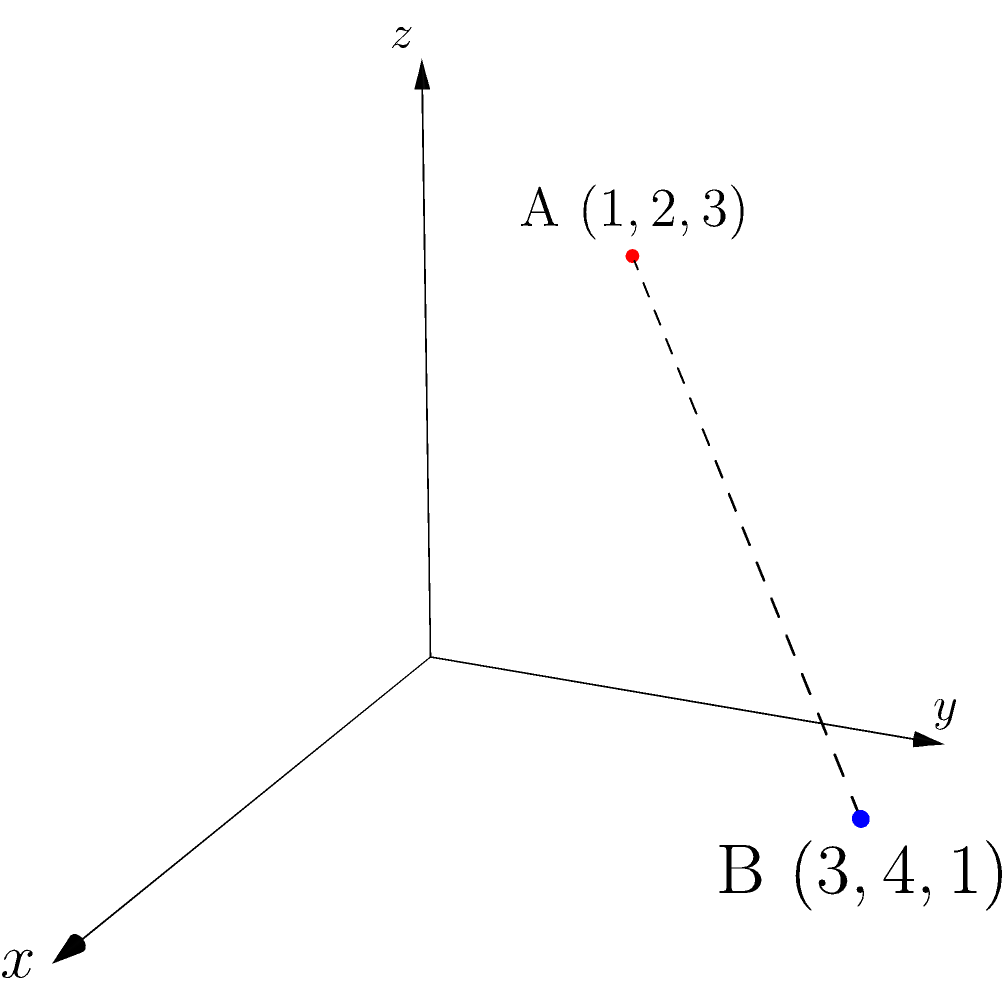In the competitive landscape of quantum computing, two products are represented by points A(1,2,3) and B(3,4,1) in a 3D space where each dimension represents a key technological attribute. Calculate the Euclidean distance between these points to quantify the technological gap between the products. How might this metric inform strategic decisions regarding intellectual property protection and R&D investments? To solve this problem, we'll use the distance formula in 3D space and then interpret the result in the context of technology and intellectual property strategy.

Step 1: Recall the distance formula in 3D space.
For two points $(x_1, y_1, z_1)$ and $(x_2, y_2, z_2)$, the distance $d$ is given by:

$$d = \sqrt{(x_2-x_1)^2 + (y_2-y_1)^2 + (z_2-z_1)^2}$$

Step 2: Identify the coordinates of the two points.
A(1,2,3) and B(3,4,1)

Step 3: Plug the values into the formula.
$$d = \sqrt{(3-1)^2 + (4-2)^2 + (1-3)^2}$$

Step 4: Simplify the expression under the square root.
$$d = \sqrt{2^2 + 2^2 + (-2)^2} = \sqrt{4 + 4 + 4} = \sqrt{12}$$

Step 5: Simplify the square root.
$$d = 2\sqrt{3} \approx 3.46$$

Interpretation:
The technological gap between the two products is approximately 3.46 units in this 3D technological space. This quantitative measure can inform several strategic decisions:

1. Intellectual Property Protection: If the distance is significant (as in this case), it might indicate unique technological advantages that should be protected through patents or trade secrets.

2. R&D Investments: The distance can guide where to focus R&D efforts. If the gap is large in a particular dimension, it might represent an opportunity for improvement or a competitive advantage to maintain.

3. Competitive Analysis: Regular mapping of products in this space can track how the technological landscape is evolving and inform strategic decision-making.

4. Licensing and Partnerships: Understanding the technological distance can help in identifying potential partners or licensing opportunities, especially if another company excels in an area where your product is lacking.

5. Market Positioning: The distance can inform how to position the product in the market, highlighting unique technological attributes that set it apart from competitors.
Answer: $2\sqrt{3}$ units; informs IP strategy, R&D focus, and market positioning 